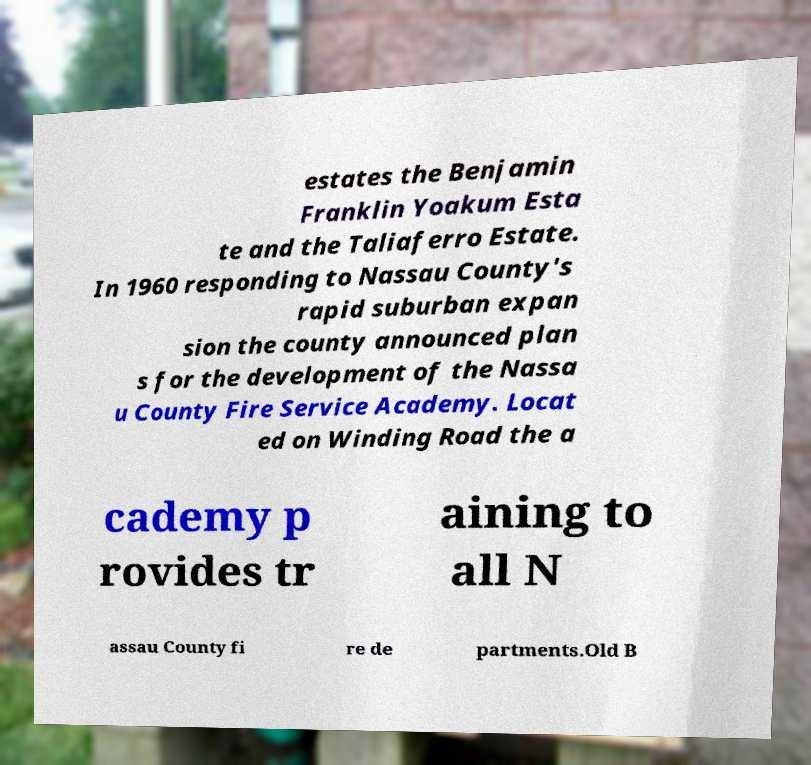For documentation purposes, I need the text within this image transcribed. Could you provide that? estates the Benjamin Franklin Yoakum Esta te and the Taliaferro Estate. In 1960 responding to Nassau County's rapid suburban expan sion the county announced plan s for the development of the Nassa u County Fire Service Academy. Locat ed on Winding Road the a cademy p rovides tr aining to all N assau County fi re de partments.Old B 